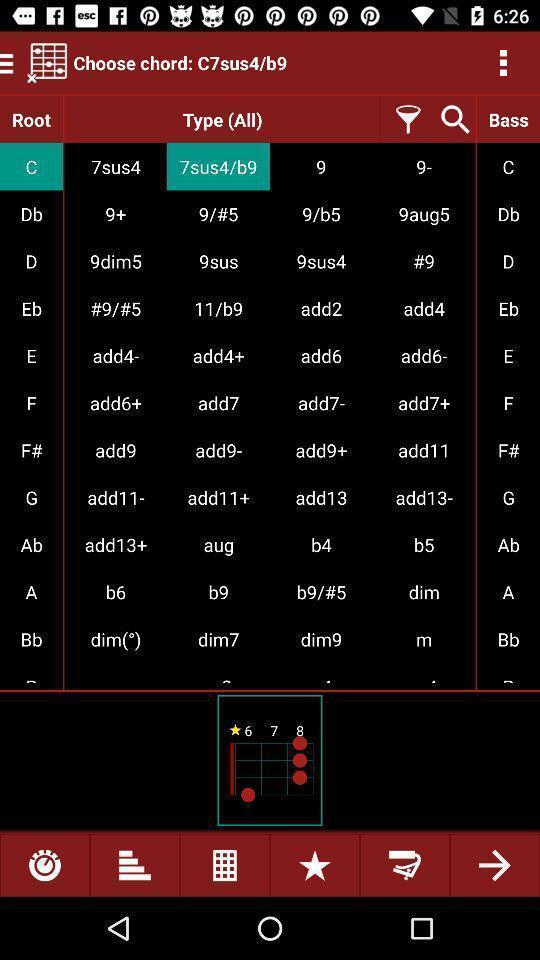Tell me about the visual elements in this screen capture. Window displaying a music app. 